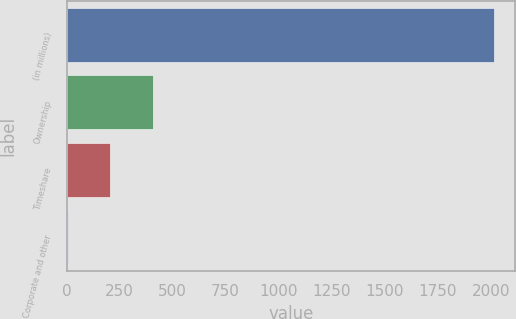<chart> <loc_0><loc_0><loc_500><loc_500><bar_chart><fcel>(in millions)<fcel>Ownership<fcel>Timeshare<fcel>Corporate and other<nl><fcel>2013<fcel>407.4<fcel>206.7<fcel>6<nl></chart> 